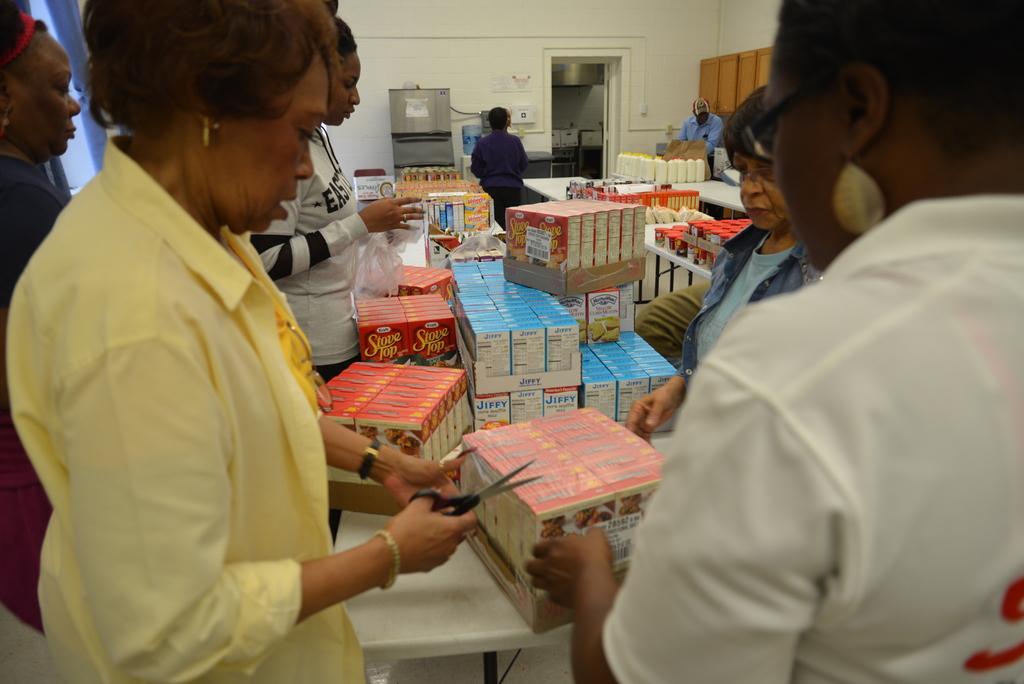How would you summarize this image in a sentence or two? In this image, I can see few people standing and there are few objects on the tables. The person on the left side is holding scissors. In the background, I can see a room and there is a kind of a machine. 